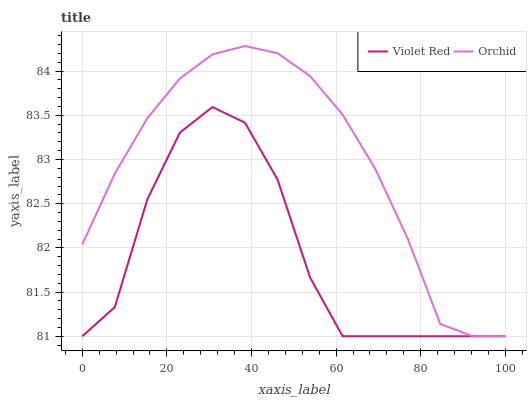Does Orchid have the minimum area under the curve?
Answer yes or no. No. Is Orchid the roughest?
Answer yes or no. No. 